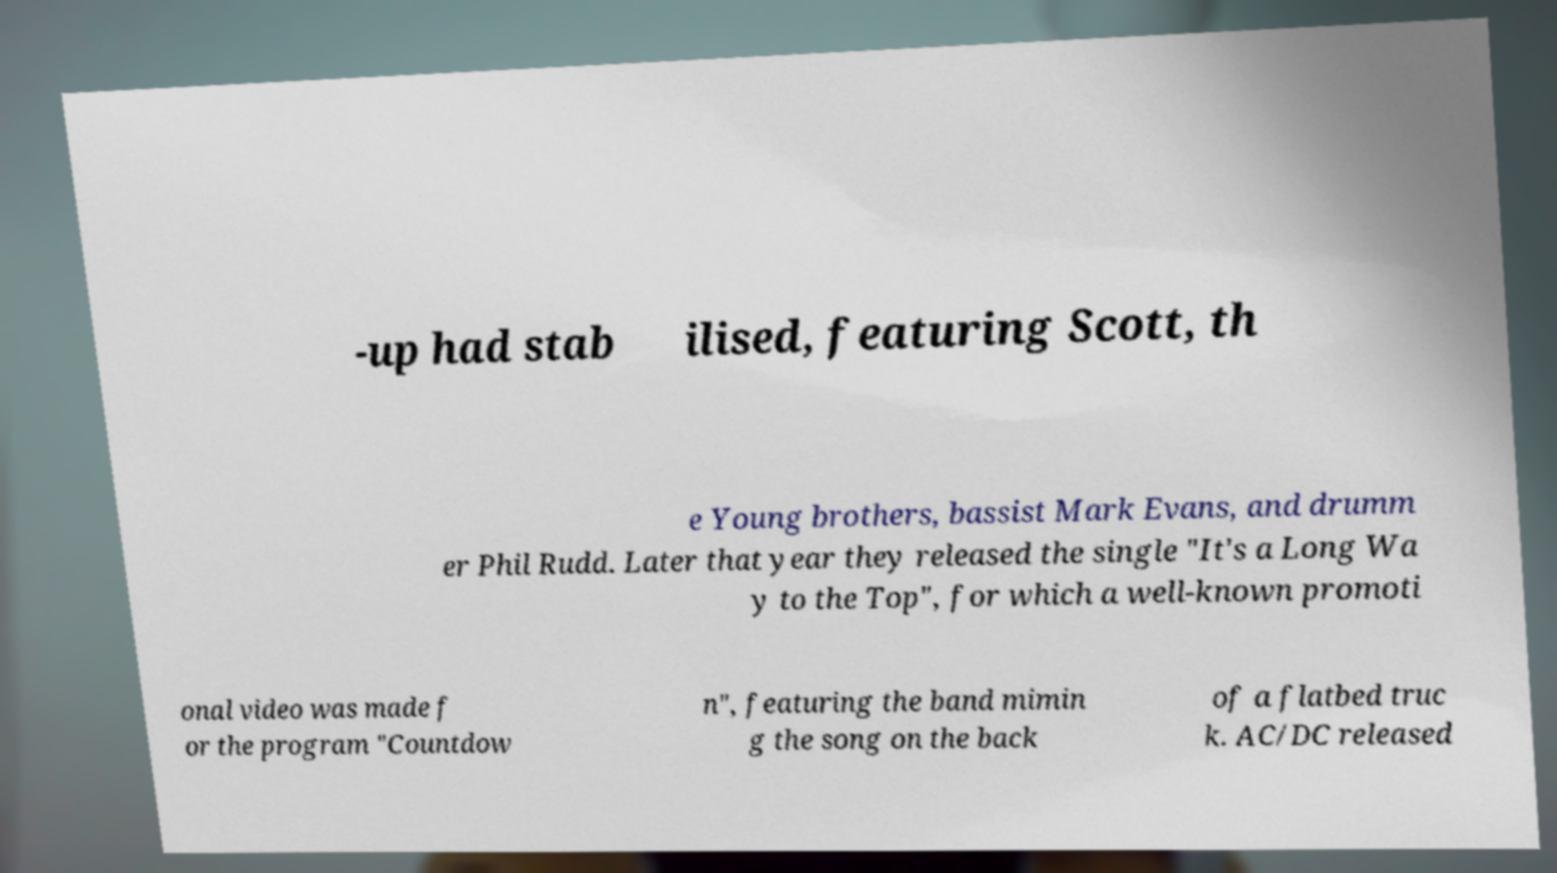Please read and relay the text visible in this image. What does it say? -up had stab ilised, featuring Scott, th e Young brothers, bassist Mark Evans, and drumm er Phil Rudd. Later that year they released the single "It's a Long Wa y to the Top", for which a well-known promoti onal video was made f or the program "Countdow n", featuring the band mimin g the song on the back of a flatbed truc k. AC/DC released 